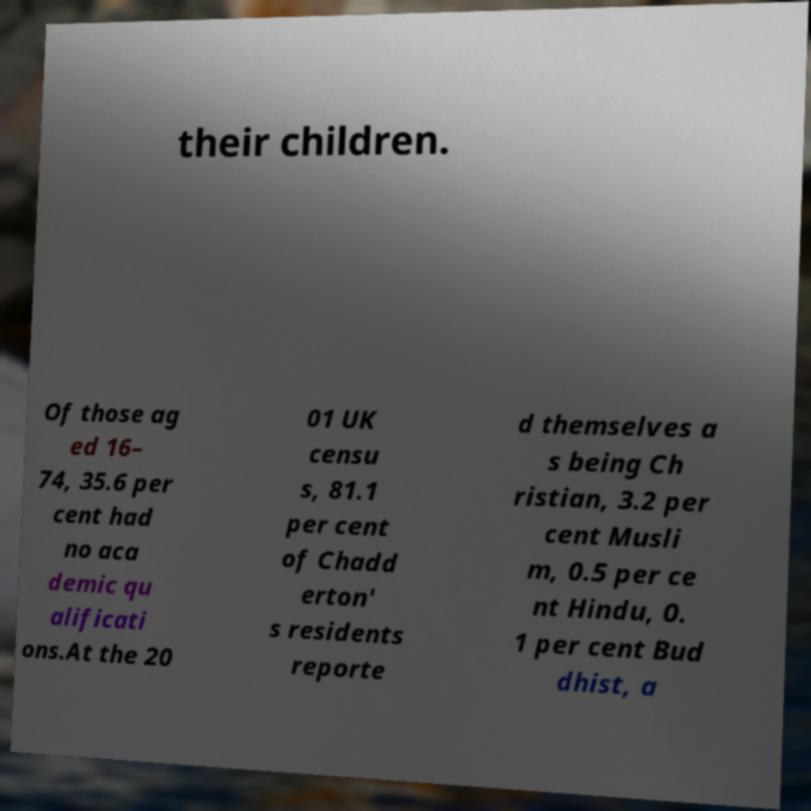Could you extract and type out the text from this image? their children. Of those ag ed 16– 74, 35.6 per cent had no aca demic qu alificati ons.At the 20 01 UK censu s, 81.1 per cent of Chadd erton' s residents reporte d themselves a s being Ch ristian, 3.2 per cent Musli m, 0.5 per ce nt Hindu, 0. 1 per cent Bud dhist, a 